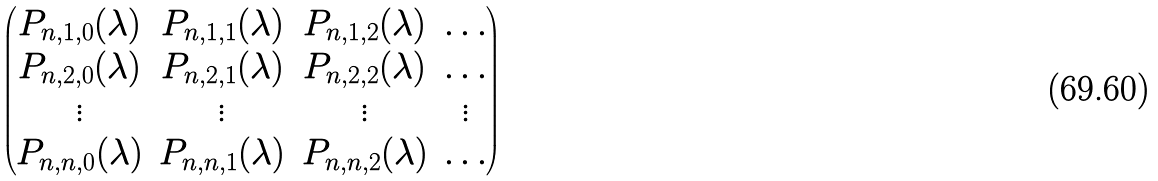<formula> <loc_0><loc_0><loc_500><loc_500>\begin{pmatrix} P _ { n , 1 , 0 } ( \lambda ) & P _ { n , 1 , 1 } ( \lambda ) & P _ { n , 1 , 2 } ( \lambda ) & \dots \\ P _ { n , 2 , 0 } ( \lambda ) & P _ { n , 2 , 1 } ( \lambda ) & P _ { n , 2 , 2 } ( \lambda ) & \dots \\ \vdots & \vdots & \vdots & \vdots \\ P _ { n , n , 0 } ( \lambda ) & P _ { n , n , 1 } ( \lambda ) & P _ { n , n , 2 } ( \lambda ) & \dots \end{pmatrix}</formula> 